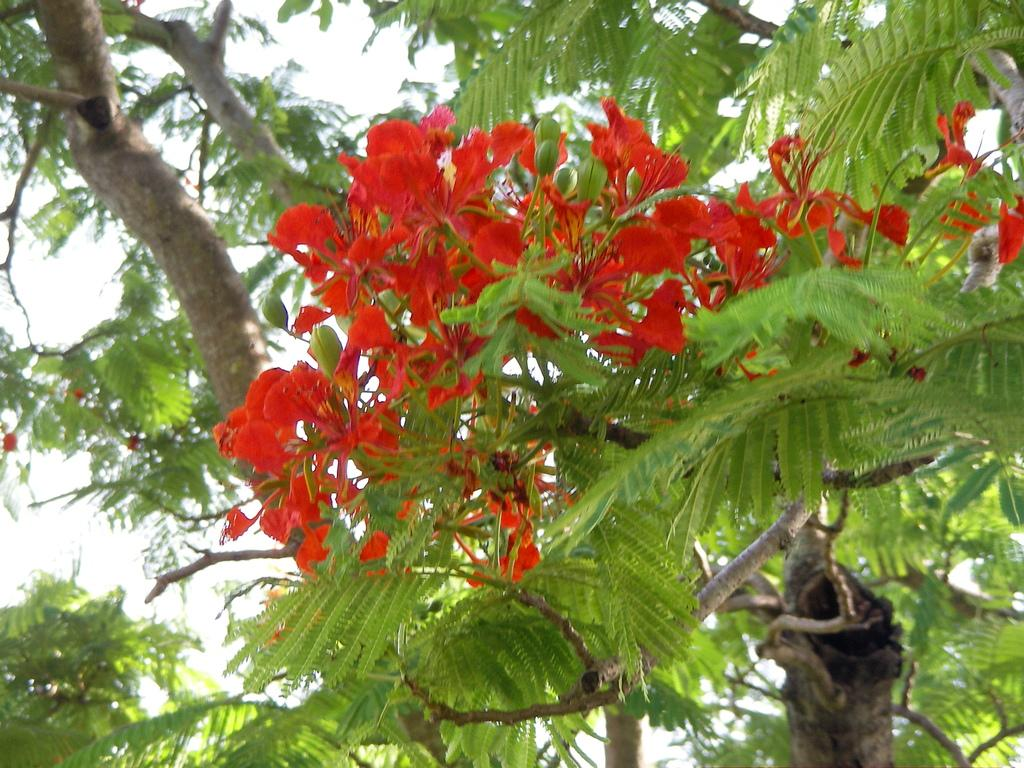What type of plants can be seen in the image? There are flowers and trees in the image. What part of the natural environment is visible in the image? The sky is visible in the background of the image. What type of record can be seen in the image? There is no record present in the image; it features flowers, trees, and the sky. What kind of beast is visible in the image? There is no beast present in the image; it only contains flowers, trees, and the sky. 